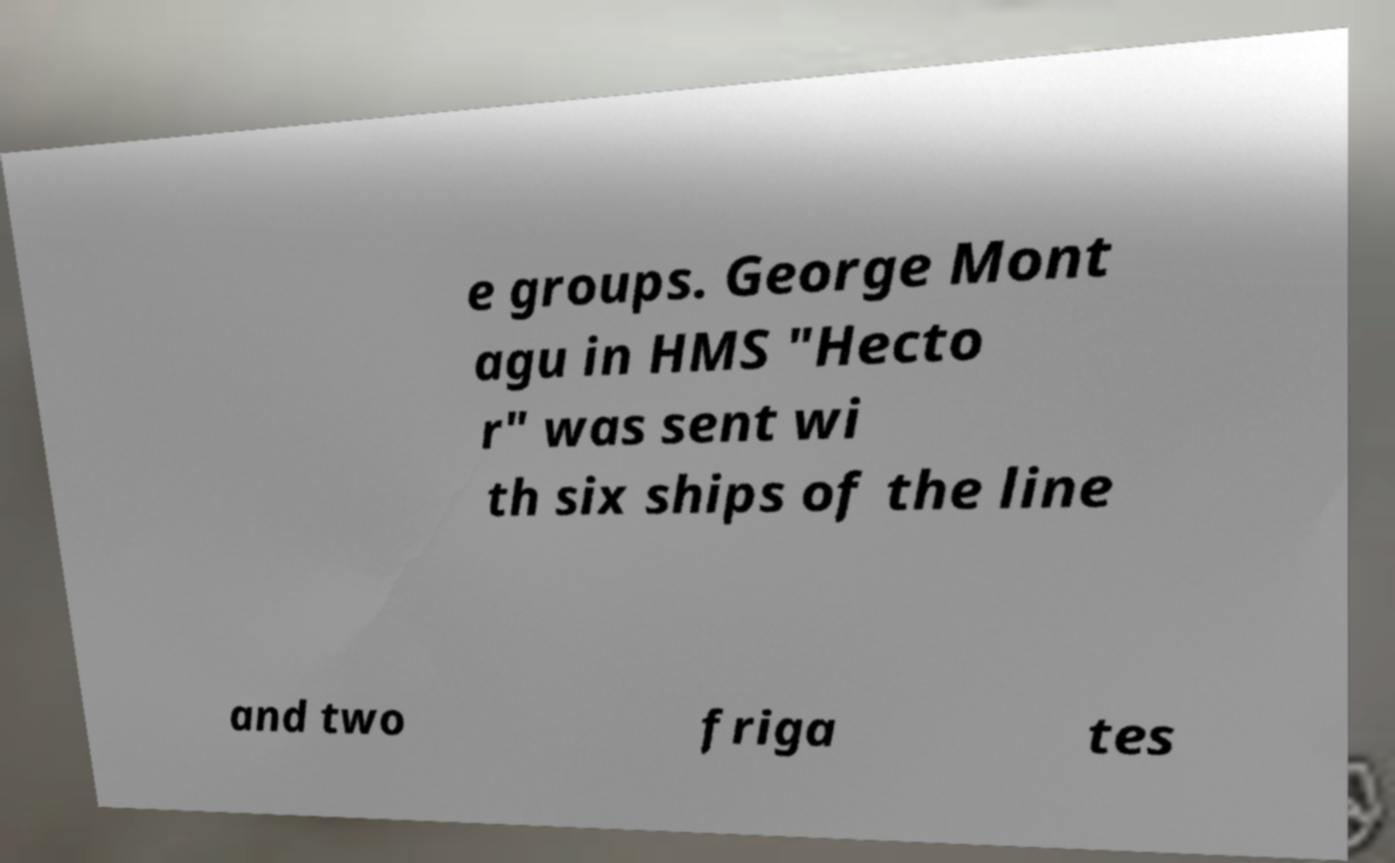Please identify and transcribe the text found in this image. e groups. George Mont agu in HMS "Hecto r" was sent wi th six ships of the line and two friga tes 